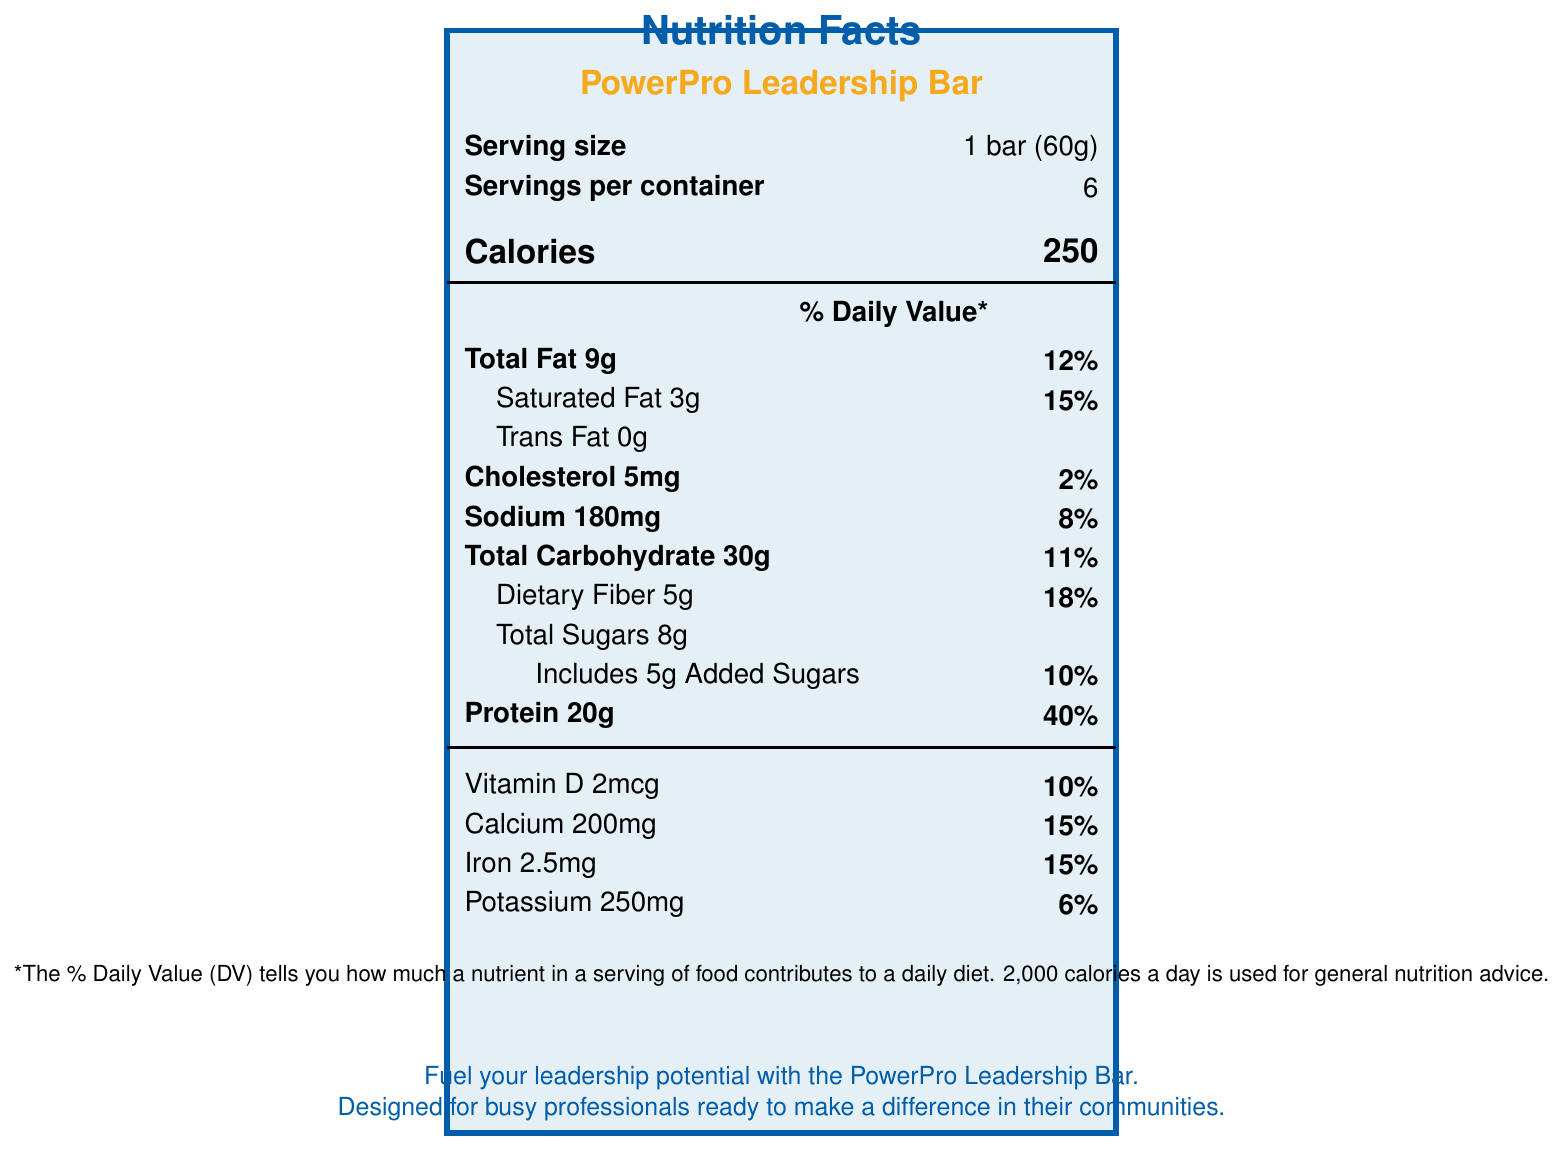what is the serving size for the PowerPro Leadership Bar? The serving size is explicitly stated on the document as 1 bar (60g).
Answer: 1 bar (60g) how many calories are there per serving? The document shows there are 250 calories per serving of the PowerPro Leadership Bar.
Answer: 250 what percentage of the daily value for protein does one bar provide? According to the document, one bar provides 40% of the daily value for protein.
Answer: 40% how much dietary fiber is in one serving? The dietary fiber content per serving is stated to be 5g in the document.
Answer: 5g how much iron does one serving contain, in terms of daily value percentage? The document specifies that one serving contains 15% of the daily value for iron.
Answer: 15% does the PowerPro Leadership Bar contain any trans fat? The document shows that the trans fat content is 0g.
Answer: No which of the following ingredients is NOT listed in the PowerPro Leadership Bar? A. Almond butter B. Flaxseed meal C. Cocoa powder D. Whey protein isolate Cocoa powder is not listed among the ingredients in the PowerPro Leadership Bar.
Answer: C what are the claim statements made about the PowerPro Leadership Bar? A. Excellent source of fiber B. Good source of fiber C. No artificial preservatives or colors D. Both B and C The claim statements are "Good source of fiber" and "No artificial preservatives or colors."
Answer: D is the PowerPro Leadership Bar recommended for people with a tree nut allergy? The document states that the bar contains tree nuts (almonds) and is manufactured in a facility that processes other allergens.
Answer: No what is the main focus of the rotary-inspired description for the PowerPro Leadership Bar? The rotary-inspired description emphasizes fueling leadership potential and supporting busy professionals in their community involvement.
Answer: Fueling leadership potential how much calcium does one serving of the PowerPro Leadership Bar provide? The document indicates that one serving provides 200mg of calcium.
Answer: 200mg what percentage of the daily value for sodium does one bar have? The sodium content per serving is listed as 8% of the daily value.
Answer: 8% if someone wants to avoid added sugars, should they consume the PowerPro Leadership Bar? The bar contains 5g of added sugars, which is 10% of the daily value. It depends on the individual's dietary preferences and limits regarding added sugars.
Answer: It depends what is not enough information provided to determine regarding the PowerPro Leadership Bar? The document does not provide enough information about the specific manufacturing processes or procedures.
Answer: The exact manufacturing process how many servings are there per container? The document states that there are 6 servings per container.
Answer: 6 briefly describe the contents and purpose of the "PowerPro Leadership Bar" nutrition label. The label provides detailed nutritional information including the amounts and daily values for various nutrients, lists ingredients and possible allergens, and makes health-related claims, all aimed at busy professionals looking to enhance their leadership potential.
Answer: The PowerPro Leadership Bar's nutrition label includes information about serving size, calories, macronutrient content (fat, carbohydrates, protein), vitamins, and minerals. It also lists the ingredients, allergen information, and claim statements like being a good source of fiber and containing no artificial preservatives. The intent is to highlight the bar's health benefits for busy professionals aiming to step out of their comfort zones and lead in their communities. 